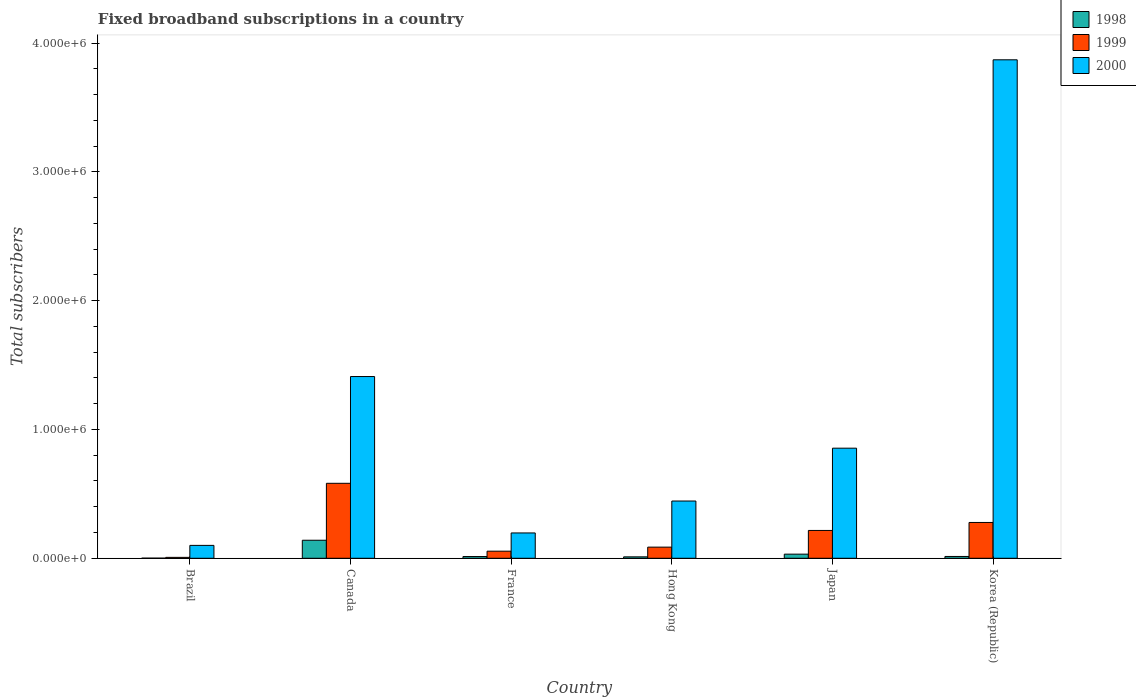How many different coloured bars are there?
Make the answer very short. 3. How many groups of bars are there?
Keep it short and to the point. 6. Are the number of bars per tick equal to the number of legend labels?
Make the answer very short. Yes. Are the number of bars on each tick of the X-axis equal?
Offer a terse response. Yes. How many bars are there on the 5th tick from the left?
Give a very brief answer. 3. What is the number of broadband subscriptions in 1999 in Korea (Republic)?
Your answer should be compact. 2.78e+05. Across all countries, what is the maximum number of broadband subscriptions in 2000?
Offer a very short reply. 3.87e+06. Across all countries, what is the minimum number of broadband subscriptions in 2000?
Offer a terse response. 1.00e+05. In which country was the number of broadband subscriptions in 1999 maximum?
Give a very brief answer. Canada. What is the total number of broadband subscriptions in 1999 in the graph?
Give a very brief answer. 1.22e+06. What is the difference between the number of broadband subscriptions in 2000 in Japan and that in Korea (Republic)?
Give a very brief answer. -3.02e+06. What is the difference between the number of broadband subscriptions in 2000 in Japan and the number of broadband subscriptions in 1999 in Hong Kong?
Provide a succinct answer. 7.68e+05. What is the average number of broadband subscriptions in 1999 per country?
Offer a terse response. 2.04e+05. What is the difference between the number of broadband subscriptions of/in 2000 and number of broadband subscriptions of/in 1999 in France?
Ensure brevity in your answer.  1.42e+05. In how many countries, is the number of broadband subscriptions in 1999 greater than 3600000?
Give a very brief answer. 0. What is the ratio of the number of broadband subscriptions in 2000 in Canada to that in Japan?
Your answer should be very brief. 1.65. Is the number of broadband subscriptions in 1998 in Canada less than that in Japan?
Keep it short and to the point. No. Is the difference between the number of broadband subscriptions in 2000 in Brazil and Canada greater than the difference between the number of broadband subscriptions in 1999 in Brazil and Canada?
Give a very brief answer. No. What is the difference between the highest and the second highest number of broadband subscriptions in 1999?
Make the answer very short. 3.04e+05. What is the difference between the highest and the lowest number of broadband subscriptions in 1998?
Make the answer very short. 1.39e+05. What does the 1st bar from the right in Korea (Republic) represents?
Your answer should be very brief. 2000. Are all the bars in the graph horizontal?
Offer a very short reply. No. What is the difference between two consecutive major ticks on the Y-axis?
Offer a very short reply. 1.00e+06. Does the graph contain grids?
Make the answer very short. No. How many legend labels are there?
Provide a short and direct response. 3. What is the title of the graph?
Provide a short and direct response. Fixed broadband subscriptions in a country. What is the label or title of the Y-axis?
Keep it short and to the point. Total subscribers. What is the Total subscribers of 1999 in Brazil?
Provide a short and direct response. 7000. What is the Total subscribers in 1998 in Canada?
Offer a very short reply. 1.40e+05. What is the Total subscribers of 1999 in Canada?
Give a very brief answer. 5.82e+05. What is the Total subscribers in 2000 in Canada?
Your answer should be very brief. 1.41e+06. What is the Total subscribers of 1998 in France?
Ensure brevity in your answer.  1.35e+04. What is the Total subscribers of 1999 in France?
Provide a succinct answer. 5.50e+04. What is the Total subscribers in 2000 in France?
Make the answer very short. 1.97e+05. What is the Total subscribers in 1998 in Hong Kong?
Offer a very short reply. 1.10e+04. What is the Total subscribers in 1999 in Hong Kong?
Provide a short and direct response. 8.65e+04. What is the Total subscribers of 2000 in Hong Kong?
Keep it short and to the point. 4.44e+05. What is the Total subscribers in 1998 in Japan?
Ensure brevity in your answer.  3.20e+04. What is the Total subscribers of 1999 in Japan?
Ensure brevity in your answer.  2.16e+05. What is the Total subscribers in 2000 in Japan?
Keep it short and to the point. 8.55e+05. What is the Total subscribers in 1998 in Korea (Republic)?
Make the answer very short. 1.40e+04. What is the Total subscribers of 1999 in Korea (Republic)?
Keep it short and to the point. 2.78e+05. What is the Total subscribers of 2000 in Korea (Republic)?
Your answer should be very brief. 3.87e+06. Across all countries, what is the maximum Total subscribers of 1998?
Give a very brief answer. 1.40e+05. Across all countries, what is the maximum Total subscribers in 1999?
Give a very brief answer. 5.82e+05. Across all countries, what is the maximum Total subscribers of 2000?
Give a very brief answer. 3.87e+06. Across all countries, what is the minimum Total subscribers of 1998?
Offer a very short reply. 1000. Across all countries, what is the minimum Total subscribers of 1999?
Ensure brevity in your answer.  7000. What is the total Total subscribers of 1998 in the graph?
Your answer should be very brief. 2.11e+05. What is the total Total subscribers of 1999 in the graph?
Offer a very short reply. 1.22e+06. What is the total Total subscribers of 2000 in the graph?
Keep it short and to the point. 6.88e+06. What is the difference between the Total subscribers in 1998 in Brazil and that in Canada?
Your answer should be compact. -1.39e+05. What is the difference between the Total subscribers of 1999 in Brazil and that in Canada?
Give a very brief answer. -5.75e+05. What is the difference between the Total subscribers in 2000 in Brazil and that in Canada?
Your response must be concise. -1.31e+06. What is the difference between the Total subscribers in 1998 in Brazil and that in France?
Offer a terse response. -1.25e+04. What is the difference between the Total subscribers of 1999 in Brazil and that in France?
Ensure brevity in your answer.  -4.80e+04. What is the difference between the Total subscribers of 2000 in Brazil and that in France?
Offer a terse response. -9.66e+04. What is the difference between the Total subscribers in 1998 in Brazil and that in Hong Kong?
Your answer should be very brief. -10000. What is the difference between the Total subscribers of 1999 in Brazil and that in Hong Kong?
Provide a succinct answer. -7.95e+04. What is the difference between the Total subscribers in 2000 in Brazil and that in Hong Kong?
Keep it short and to the point. -3.44e+05. What is the difference between the Total subscribers in 1998 in Brazil and that in Japan?
Your response must be concise. -3.10e+04. What is the difference between the Total subscribers in 1999 in Brazil and that in Japan?
Your answer should be compact. -2.09e+05. What is the difference between the Total subscribers in 2000 in Brazil and that in Japan?
Your answer should be compact. -7.55e+05. What is the difference between the Total subscribers of 1998 in Brazil and that in Korea (Republic)?
Make the answer very short. -1.30e+04. What is the difference between the Total subscribers of 1999 in Brazil and that in Korea (Republic)?
Ensure brevity in your answer.  -2.71e+05. What is the difference between the Total subscribers in 2000 in Brazil and that in Korea (Republic)?
Keep it short and to the point. -3.77e+06. What is the difference between the Total subscribers in 1998 in Canada and that in France?
Offer a terse response. 1.27e+05. What is the difference between the Total subscribers of 1999 in Canada and that in France?
Offer a terse response. 5.27e+05. What is the difference between the Total subscribers of 2000 in Canada and that in France?
Make the answer very short. 1.21e+06. What is the difference between the Total subscribers in 1998 in Canada and that in Hong Kong?
Your answer should be compact. 1.29e+05. What is the difference between the Total subscribers of 1999 in Canada and that in Hong Kong?
Provide a short and direct response. 4.96e+05. What is the difference between the Total subscribers of 2000 in Canada and that in Hong Kong?
Your response must be concise. 9.66e+05. What is the difference between the Total subscribers in 1998 in Canada and that in Japan?
Provide a short and direct response. 1.08e+05. What is the difference between the Total subscribers in 1999 in Canada and that in Japan?
Keep it short and to the point. 3.66e+05. What is the difference between the Total subscribers in 2000 in Canada and that in Japan?
Provide a succinct answer. 5.56e+05. What is the difference between the Total subscribers of 1998 in Canada and that in Korea (Republic)?
Offer a very short reply. 1.26e+05. What is the difference between the Total subscribers in 1999 in Canada and that in Korea (Republic)?
Your answer should be very brief. 3.04e+05. What is the difference between the Total subscribers in 2000 in Canada and that in Korea (Republic)?
Your answer should be compact. -2.46e+06. What is the difference between the Total subscribers of 1998 in France and that in Hong Kong?
Provide a short and direct response. 2464. What is the difference between the Total subscribers in 1999 in France and that in Hong Kong?
Make the answer very short. -3.15e+04. What is the difference between the Total subscribers in 2000 in France and that in Hong Kong?
Offer a terse response. -2.48e+05. What is the difference between the Total subscribers in 1998 in France and that in Japan?
Provide a succinct answer. -1.85e+04. What is the difference between the Total subscribers of 1999 in France and that in Japan?
Your answer should be compact. -1.61e+05. What is the difference between the Total subscribers of 2000 in France and that in Japan?
Your answer should be very brief. -6.58e+05. What is the difference between the Total subscribers in 1998 in France and that in Korea (Republic)?
Keep it short and to the point. -536. What is the difference between the Total subscribers in 1999 in France and that in Korea (Republic)?
Your answer should be compact. -2.23e+05. What is the difference between the Total subscribers in 2000 in France and that in Korea (Republic)?
Ensure brevity in your answer.  -3.67e+06. What is the difference between the Total subscribers of 1998 in Hong Kong and that in Japan?
Keep it short and to the point. -2.10e+04. What is the difference between the Total subscribers of 1999 in Hong Kong and that in Japan?
Your answer should be compact. -1.30e+05. What is the difference between the Total subscribers in 2000 in Hong Kong and that in Japan?
Make the answer very short. -4.10e+05. What is the difference between the Total subscribers of 1998 in Hong Kong and that in Korea (Republic)?
Provide a succinct answer. -3000. What is the difference between the Total subscribers in 1999 in Hong Kong and that in Korea (Republic)?
Offer a terse response. -1.92e+05. What is the difference between the Total subscribers in 2000 in Hong Kong and that in Korea (Republic)?
Your response must be concise. -3.43e+06. What is the difference between the Total subscribers in 1998 in Japan and that in Korea (Republic)?
Keep it short and to the point. 1.80e+04. What is the difference between the Total subscribers in 1999 in Japan and that in Korea (Republic)?
Provide a succinct answer. -6.20e+04. What is the difference between the Total subscribers in 2000 in Japan and that in Korea (Republic)?
Provide a succinct answer. -3.02e+06. What is the difference between the Total subscribers in 1998 in Brazil and the Total subscribers in 1999 in Canada?
Keep it short and to the point. -5.81e+05. What is the difference between the Total subscribers of 1998 in Brazil and the Total subscribers of 2000 in Canada?
Provide a succinct answer. -1.41e+06. What is the difference between the Total subscribers in 1999 in Brazil and the Total subscribers in 2000 in Canada?
Your answer should be compact. -1.40e+06. What is the difference between the Total subscribers in 1998 in Brazil and the Total subscribers in 1999 in France?
Ensure brevity in your answer.  -5.40e+04. What is the difference between the Total subscribers of 1998 in Brazil and the Total subscribers of 2000 in France?
Provide a succinct answer. -1.96e+05. What is the difference between the Total subscribers of 1999 in Brazil and the Total subscribers of 2000 in France?
Provide a short and direct response. -1.90e+05. What is the difference between the Total subscribers in 1998 in Brazil and the Total subscribers in 1999 in Hong Kong?
Your response must be concise. -8.55e+04. What is the difference between the Total subscribers of 1998 in Brazil and the Total subscribers of 2000 in Hong Kong?
Provide a succinct answer. -4.43e+05. What is the difference between the Total subscribers in 1999 in Brazil and the Total subscribers in 2000 in Hong Kong?
Provide a short and direct response. -4.37e+05. What is the difference between the Total subscribers in 1998 in Brazil and the Total subscribers in 1999 in Japan?
Provide a succinct answer. -2.15e+05. What is the difference between the Total subscribers in 1998 in Brazil and the Total subscribers in 2000 in Japan?
Make the answer very short. -8.54e+05. What is the difference between the Total subscribers in 1999 in Brazil and the Total subscribers in 2000 in Japan?
Your response must be concise. -8.48e+05. What is the difference between the Total subscribers in 1998 in Brazil and the Total subscribers in 1999 in Korea (Republic)?
Provide a short and direct response. -2.77e+05. What is the difference between the Total subscribers in 1998 in Brazil and the Total subscribers in 2000 in Korea (Republic)?
Ensure brevity in your answer.  -3.87e+06. What is the difference between the Total subscribers of 1999 in Brazil and the Total subscribers of 2000 in Korea (Republic)?
Your answer should be very brief. -3.86e+06. What is the difference between the Total subscribers of 1998 in Canada and the Total subscribers of 1999 in France?
Provide a succinct answer. 8.50e+04. What is the difference between the Total subscribers of 1998 in Canada and the Total subscribers of 2000 in France?
Offer a terse response. -5.66e+04. What is the difference between the Total subscribers in 1999 in Canada and the Total subscribers in 2000 in France?
Offer a very short reply. 3.85e+05. What is the difference between the Total subscribers in 1998 in Canada and the Total subscribers in 1999 in Hong Kong?
Your response must be concise. 5.35e+04. What is the difference between the Total subscribers in 1998 in Canada and the Total subscribers in 2000 in Hong Kong?
Offer a very short reply. -3.04e+05. What is the difference between the Total subscribers of 1999 in Canada and the Total subscribers of 2000 in Hong Kong?
Your response must be concise. 1.38e+05. What is the difference between the Total subscribers in 1998 in Canada and the Total subscribers in 1999 in Japan?
Make the answer very short. -7.60e+04. What is the difference between the Total subscribers of 1998 in Canada and the Total subscribers of 2000 in Japan?
Offer a very short reply. -7.15e+05. What is the difference between the Total subscribers in 1999 in Canada and the Total subscribers in 2000 in Japan?
Provide a short and direct response. -2.73e+05. What is the difference between the Total subscribers in 1998 in Canada and the Total subscribers in 1999 in Korea (Republic)?
Your answer should be very brief. -1.38e+05. What is the difference between the Total subscribers of 1998 in Canada and the Total subscribers of 2000 in Korea (Republic)?
Give a very brief answer. -3.73e+06. What is the difference between the Total subscribers of 1999 in Canada and the Total subscribers of 2000 in Korea (Republic)?
Your response must be concise. -3.29e+06. What is the difference between the Total subscribers of 1998 in France and the Total subscribers of 1999 in Hong Kong?
Ensure brevity in your answer.  -7.30e+04. What is the difference between the Total subscribers of 1998 in France and the Total subscribers of 2000 in Hong Kong?
Provide a short and direct response. -4.31e+05. What is the difference between the Total subscribers of 1999 in France and the Total subscribers of 2000 in Hong Kong?
Offer a terse response. -3.89e+05. What is the difference between the Total subscribers of 1998 in France and the Total subscribers of 1999 in Japan?
Offer a very short reply. -2.03e+05. What is the difference between the Total subscribers of 1998 in France and the Total subscribers of 2000 in Japan?
Ensure brevity in your answer.  -8.41e+05. What is the difference between the Total subscribers in 1999 in France and the Total subscribers in 2000 in Japan?
Keep it short and to the point. -8.00e+05. What is the difference between the Total subscribers in 1998 in France and the Total subscribers in 1999 in Korea (Republic)?
Give a very brief answer. -2.65e+05. What is the difference between the Total subscribers in 1998 in France and the Total subscribers in 2000 in Korea (Republic)?
Provide a short and direct response. -3.86e+06. What is the difference between the Total subscribers in 1999 in France and the Total subscribers in 2000 in Korea (Republic)?
Make the answer very short. -3.82e+06. What is the difference between the Total subscribers of 1998 in Hong Kong and the Total subscribers of 1999 in Japan?
Your answer should be very brief. -2.05e+05. What is the difference between the Total subscribers in 1998 in Hong Kong and the Total subscribers in 2000 in Japan?
Give a very brief answer. -8.44e+05. What is the difference between the Total subscribers in 1999 in Hong Kong and the Total subscribers in 2000 in Japan?
Ensure brevity in your answer.  -7.68e+05. What is the difference between the Total subscribers of 1998 in Hong Kong and the Total subscribers of 1999 in Korea (Republic)?
Ensure brevity in your answer.  -2.67e+05. What is the difference between the Total subscribers of 1998 in Hong Kong and the Total subscribers of 2000 in Korea (Republic)?
Offer a very short reply. -3.86e+06. What is the difference between the Total subscribers in 1999 in Hong Kong and the Total subscribers in 2000 in Korea (Republic)?
Your response must be concise. -3.78e+06. What is the difference between the Total subscribers in 1998 in Japan and the Total subscribers in 1999 in Korea (Republic)?
Keep it short and to the point. -2.46e+05. What is the difference between the Total subscribers in 1998 in Japan and the Total subscribers in 2000 in Korea (Republic)?
Your answer should be very brief. -3.84e+06. What is the difference between the Total subscribers in 1999 in Japan and the Total subscribers in 2000 in Korea (Republic)?
Offer a terse response. -3.65e+06. What is the average Total subscribers in 1998 per country?
Your answer should be compact. 3.52e+04. What is the average Total subscribers of 1999 per country?
Provide a succinct answer. 2.04e+05. What is the average Total subscribers of 2000 per country?
Give a very brief answer. 1.15e+06. What is the difference between the Total subscribers of 1998 and Total subscribers of 1999 in Brazil?
Give a very brief answer. -6000. What is the difference between the Total subscribers of 1998 and Total subscribers of 2000 in Brazil?
Your response must be concise. -9.90e+04. What is the difference between the Total subscribers of 1999 and Total subscribers of 2000 in Brazil?
Give a very brief answer. -9.30e+04. What is the difference between the Total subscribers of 1998 and Total subscribers of 1999 in Canada?
Ensure brevity in your answer.  -4.42e+05. What is the difference between the Total subscribers of 1998 and Total subscribers of 2000 in Canada?
Ensure brevity in your answer.  -1.27e+06. What is the difference between the Total subscribers of 1999 and Total subscribers of 2000 in Canada?
Your response must be concise. -8.29e+05. What is the difference between the Total subscribers in 1998 and Total subscribers in 1999 in France?
Your answer should be compact. -4.15e+04. What is the difference between the Total subscribers in 1998 and Total subscribers in 2000 in France?
Keep it short and to the point. -1.83e+05. What is the difference between the Total subscribers in 1999 and Total subscribers in 2000 in France?
Keep it short and to the point. -1.42e+05. What is the difference between the Total subscribers in 1998 and Total subscribers in 1999 in Hong Kong?
Give a very brief answer. -7.55e+04. What is the difference between the Total subscribers in 1998 and Total subscribers in 2000 in Hong Kong?
Make the answer very short. -4.33e+05. What is the difference between the Total subscribers in 1999 and Total subscribers in 2000 in Hong Kong?
Your answer should be compact. -3.58e+05. What is the difference between the Total subscribers in 1998 and Total subscribers in 1999 in Japan?
Ensure brevity in your answer.  -1.84e+05. What is the difference between the Total subscribers of 1998 and Total subscribers of 2000 in Japan?
Offer a very short reply. -8.23e+05. What is the difference between the Total subscribers of 1999 and Total subscribers of 2000 in Japan?
Keep it short and to the point. -6.39e+05. What is the difference between the Total subscribers in 1998 and Total subscribers in 1999 in Korea (Republic)?
Offer a terse response. -2.64e+05. What is the difference between the Total subscribers in 1998 and Total subscribers in 2000 in Korea (Republic)?
Ensure brevity in your answer.  -3.86e+06. What is the difference between the Total subscribers of 1999 and Total subscribers of 2000 in Korea (Republic)?
Offer a very short reply. -3.59e+06. What is the ratio of the Total subscribers of 1998 in Brazil to that in Canada?
Your answer should be very brief. 0.01. What is the ratio of the Total subscribers in 1999 in Brazil to that in Canada?
Keep it short and to the point. 0.01. What is the ratio of the Total subscribers in 2000 in Brazil to that in Canada?
Make the answer very short. 0.07. What is the ratio of the Total subscribers of 1998 in Brazil to that in France?
Provide a succinct answer. 0.07. What is the ratio of the Total subscribers in 1999 in Brazil to that in France?
Your answer should be compact. 0.13. What is the ratio of the Total subscribers in 2000 in Brazil to that in France?
Offer a terse response. 0.51. What is the ratio of the Total subscribers in 1998 in Brazil to that in Hong Kong?
Ensure brevity in your answer.  0.09. What is the ratio of the Total subscribers in 1999 in Brazil to that in Hong Kong?
Your answer should be compact. 0.08. What is the ratio of the Total subscribers in 2000 in Brazil to that in Hong Kong?
Give a very brief answer. 0.23. What is the ratio of the Total subscribers of 1998 in Brazil to that in Japan?
Give a very brief answer. 0.03. What is the ratio of the Total subscribers in 1999 in Brazil to that in Japan?
Provide a succinct answer. 0.03. What is the ratio of the Total subscribers in 2000 in Brazil to that in Japan?
Provide a short and direct response. 0.12. What is the ratio of the Total subscribers of 1998 in Brazil to that in Korea (Republic)?
Provide a succinct answer. 0.07. What is the ratio of the Total subscribers in 1999 in Brazil to that in Korea (Republic)?
Your answer should be compact. 0.03. What is the ratio of the Total subscribers of 2000 in Brazil to that in Korea (Republic)?
Keep it short and to the point. 0.03. What is the ratio of the Total subscribers of 1998 in Canada to that in France?
Keep it short and to the point. 10.4. What is the ratio of the Total subscribers in 1999 in Canada to that in France?
Your response must be concise. 10.58. What is the ratio of the Total subscribers of 2000 in Canada to that in France?
Make the answer very short. 7.18. What is the ratio of the Total subscribers in 1998 in Canada to that in Hong Kong?
Make the answer very short. 12.73. What is the ratio of the Total subscribers in 1999 in Canada to that in Hong Kong?
Give a very brief answer. 6.73. What is the ratio of the Total subscribers of 2000 in Canada to that in Hong Kong?
Provide a succinct answer. 3.17. What is the ratio of the Total subscribers of 1998 in Canada to that in Japan?
Make the answer very short. 4.38. What is the ratio of the Total subscribers of 1999 in Canada to that in Japan?
Your answer should be compact. 2.69. What is the ratio of the Total subscribers of 2000 in Canada to that in Japan?
Keep it short and to the point. 1.65. What is the ratio of the Total subscribers of 1998 in Canada to that in Korea (Republic)?
Give a very brief answer. 10. What is the ratio of the Total subscribers in 1999 in Canada to that in Korea (Republic)?
Your answer should be very brief. 2.09. What is the ratio of the Total subscribers of 2000 in Canada to that in Korea (Republic)?
Keep it short and to the point. 0.36. What is the ratio of the Total subscribers of 1998 in France to that in Hong Kong?
Your answer should be very brief. 1.22. What is the ratio of the Total subscribers in 1999 in France to that in Hong Kong?
Ensure brevity in your answer.  0.64. What is the ratio of the Total subscribers in 2000 in France to that in Hong Kong?
Offer a very short reply. 0.44. What is the ratio of the Total subscribers in 1998 in France to that in Japan?
Provide a short and direct response. 0.42. What is the ratio of the Total subscribers in 1999 in France to that in Japan?
Your answer should be very brief. 0.25. What is the ratio of the Total subscribers in 2000 in France to that in Japan?
Make the answer very short. 0.23. What is the ratio of the Total subscribers in 1998 in France to that in Korea (Republic)?
Ensure brevity in your answer.  0.96. What is the ratio of the Total subscribers of 1999 in France to that in Korea (Republic)?
Give a very brief answer. 0.2. What is the ratio of the Total subscribers in 2000 in France to that in Korea (Republic)?
Your answer should be very brief. 0.05. What is the ratio of the Total subscribers in 1998 in Hong Kong to that in Japan?
Your answer should be compact. 0.34. What is the ratio of the Total subscribers in 1999 in Hong Kong to that in Japan?
Offer a terse response. 0.4. What is the ratio of the Total subscribers of 2000 in Hong Kong to that in Japan?
Provide a short and direct response. 0.52. What is the ratio of the Total subscribers in 1998 in Hong Kong to that in Korea (Republic)?
Your response must be concise. 0.79. What is the ratio of the Total subscribers in 1999 in Hong Kong to that in Korea (Republic)?
Ensure brevity in your answer.  0.31. What is the ratio of the Total subscribers in 2000 in Hong Kong to that in Korea (Republic)?
Provide a short and direct response. 0.11. What is the ratio of the Total subscribers in 1998 in Japan to that in Korea (Republic)?
Provide a short and direct response. 2.29. What is the ratio of the Total subscribers of 1999 in Japan to that in Korea (Republic)?
Ensure brevity in your answer.  0.78. What is the ratio of the Total subscribers of 2000 in Japan to that in Korea (Republic)?
Offer a very short reply. 0.22. What is the difference between the highest and the second highest Total subscribers of 1998?
Your answer should be very brief. 1.08e+05. What is the difference between the highest and the second highest Total subscribers in 1999?
Provide a short and direct response. 3.04e+05. What is the difference between the highest and the second highest Total subscribers in 2000?
Your response must be concise. 2.46e+06. What is the difference between the highest and the lowest Total subscribers in 1998?
Ensure brevity in your answer.  1.39e+05. What is the difference between the highest and the lowest Total subscribers of 1999?
Your answer should be very brief. 5.75e+05. What is the difference between the highest and the lowest Total subscribers in 2000?
Offer a very short reply. 3.77e+06. 